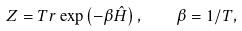<formula> <loc_0><loc_0><loc_500><loc_500>Z = T r \exp \left ( - \beta \hat { H } \right ) , \quad \beta = 1 / T ,</formula> 